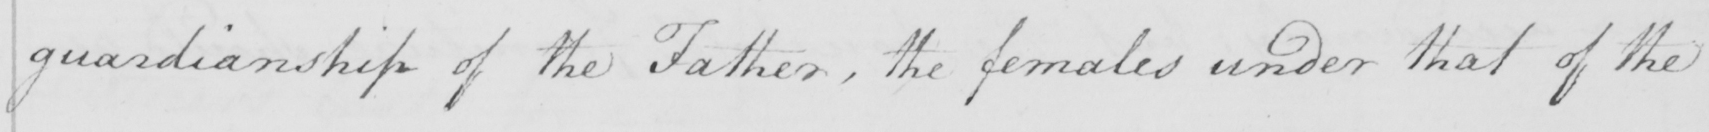Can you read and transcribe this handwriting? guardianship of the Father , the females under that of the 